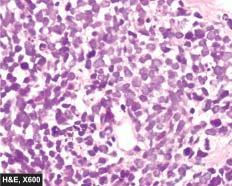re the individual tumour cells small, uniform, lymphocyte-like with scanty cytoplasm?
Answer the question using a single word or phrase. Yes 